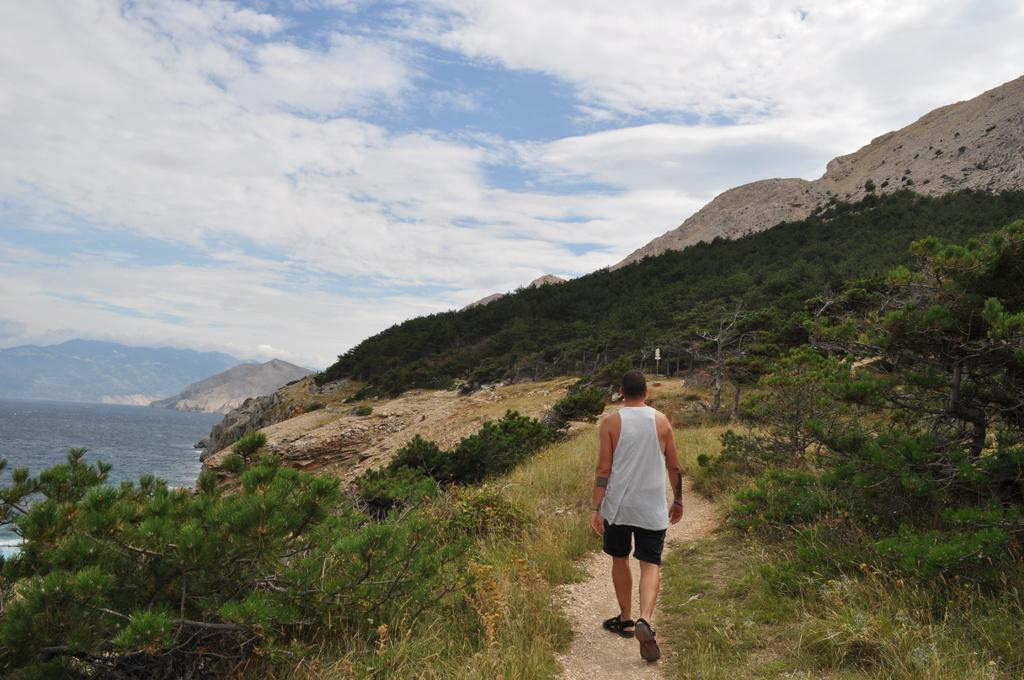What is the main subject of the image? There is a man walking in the center of the image. What type of natural environment is depicted in the image? There are trees, water, hills, and grass visible in the image. What is visible in the background of the image? The sky and hills are visible in the background of the image. Where is the nearest store to the scene in the image? The image does not provide information about a store, so it cannot be determined from the image. 